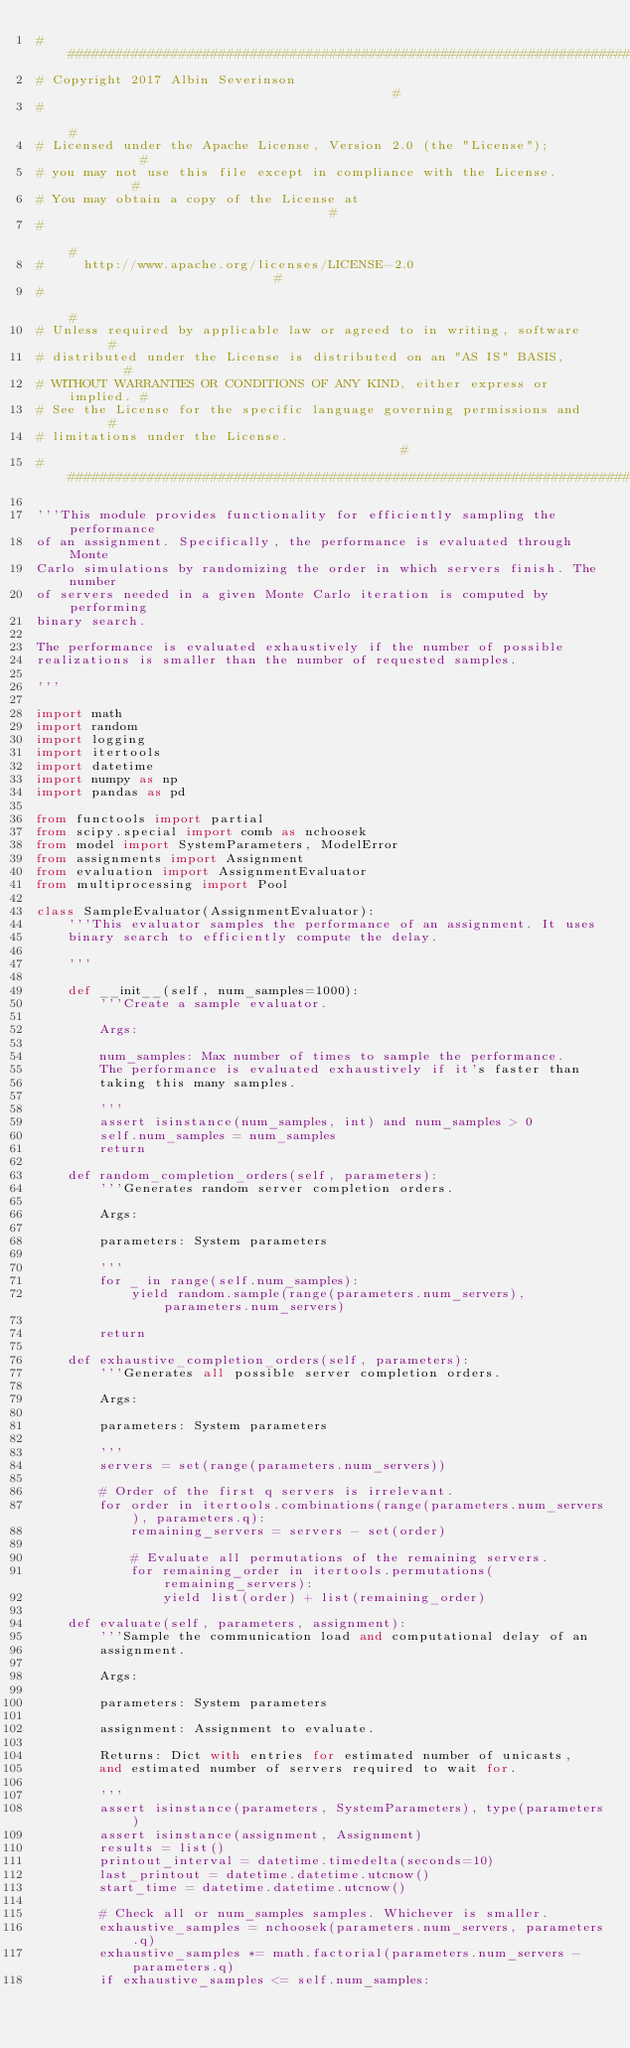Convert code to text. <code><loc_0><loc_0><loc_500><loc_500><_Python_>############################################################################
# Copyright 2017 Albin Severinson                                          #
#                                                                          #
# Licensed under the Apache License, Version 2.0 (the "License");          #
# you may not use this file except in compliance with the License.         #
# You may obtain a copy of the License at                                  #
#                                                                          #
#     http://www.apache.org/licenses/LICENSE-2.0                           #
#                                                                          #
# Unless required by applicable law or agreed to in writing, software      #
# distributed under the License is distributed on an "AS IS" BASIS,        #
# WITHOUT WARRANTIES OR CONDITIONS OF ANY KIND, either express or implied. #
# See the License for the specific language governing permissions and      #
# limitations under the License.                                           #
############################################################################

'''This module provides functionality for efficiently sampling the performance
of an assignment. Specifically, the performance is evaluated through Monte
Carlo simulations by randomizing the order in which servers finish. The number
of servers needed in a given Monte Carlo iteration is computed by performing
binary search.

The performance is evaluated exhaustively if the number of possible
realizations is smaller than the number of requested samples.

'''

import math
import random
import logging
import itertools
import datetime
import numpy as np
import pandas as pd

from functools import partial
from scipy.special import comb as nchoosek
from model import SystemParameters, ModelError
from assignments import Assignment
from evaluation import AssignmentEvaluator
from multiprocessing import Pool

class SampleEvaluator(AssignmentEvaluator):
    '''This evaluator samples the performance of an assignment. It uses
    binary search to efficiently compute the delay.

    '''

    def __init__(self, num_samples=1000):
        '''Create a sample evaluator.

        Args:

        num_samples: Max number of times to sample the performance.
        The performance is evaluated exhaustively if it's faster than
        taking this many samples.

        '''
        assert isinstance(num_samples, int) and num_samples > 0
        self.num_samples = num_samples
        return

    def random_completion_orders(self, parameters):
        '''Generates random server completion orders.

        Args:

        parameters: System parameters

        '''
        for _ in range(self.num_samples):
            yield random.sample(range(parameters.num_servers), parameters.num_servers)

        return

    def exhaustive_completion_orders(self, parameters):
        '''Generates all possible server completion orders.

        Args:

        parameters: System parameters

        '''
        servers = set(range(parameters.num_servers))

        # Order of the first q servers is irrelevant.
        for order in itertools.combinations(range(parameters.num_servers), parameters.q):
            remaining_servers = servers - set(order)

            # Evaluate all permutations of the remaining servers.
            for remaining_order in itertools.permutations(remaining_servers):
                yield list(order) + list(remaining_order)

    def evaluate(self, parameters, assignment):
        '''Sample the communication load and computational delay of an
        assignment.

        Args:

        parameters: System parameters

        assignment: Assignment to evaluate.

        Returns: Dict with entries for estimated number of unicasts,
        and estimated number of servers required to wait for.

        '''
        assert isinstance(parameters, SystemParameters), type(parameters)
        assert isinstance(assignment, Assignment)
        results = list()
        printout_interval = datetime.timedelta(seconds=10)
        last_printout = datetime.datetime.utcnow()
        start_time = datetime.datetime.utcnow()

        # Check all or num_samples samples. Whichever is smaller.
        exhaustive_samples = nchoosek(parameters.num_servers, parameters.q)
        exhaustive_samples *= math.factorial(parameters.num_servers - parameters.q)
        if exhaustive_samples <= self.num_samples:</code> 